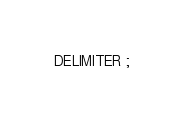<code> <loc_0><loc_0><loc_500><loc_500><_SQL_>DELIMITER ;
</code> 